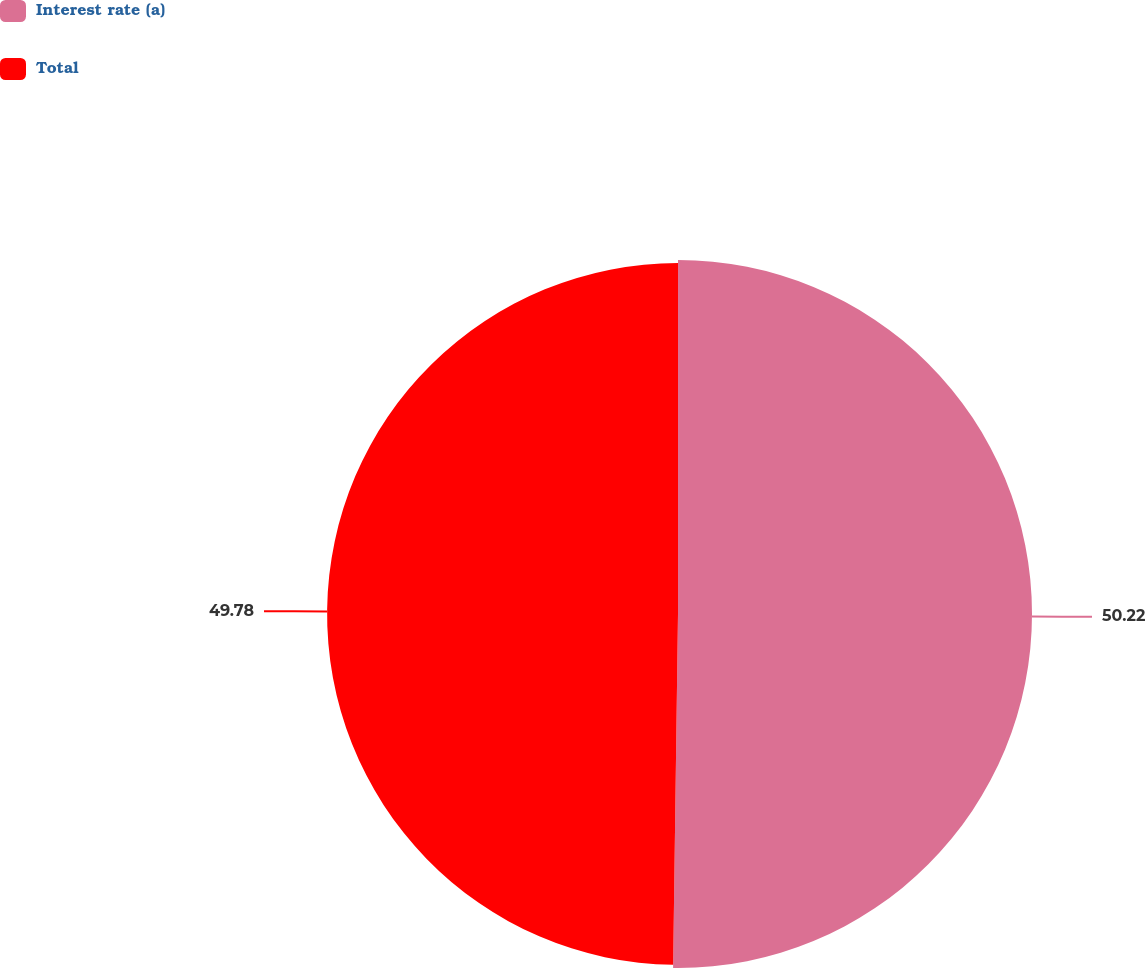Convert chart. <chart><loc_0><loc_0><loc_500><loc_500><pie_chart><fcel>Interest rate (a)<fcel>Total<nl><fcel>50.22%<fcel>49.78%<nl></chart> 